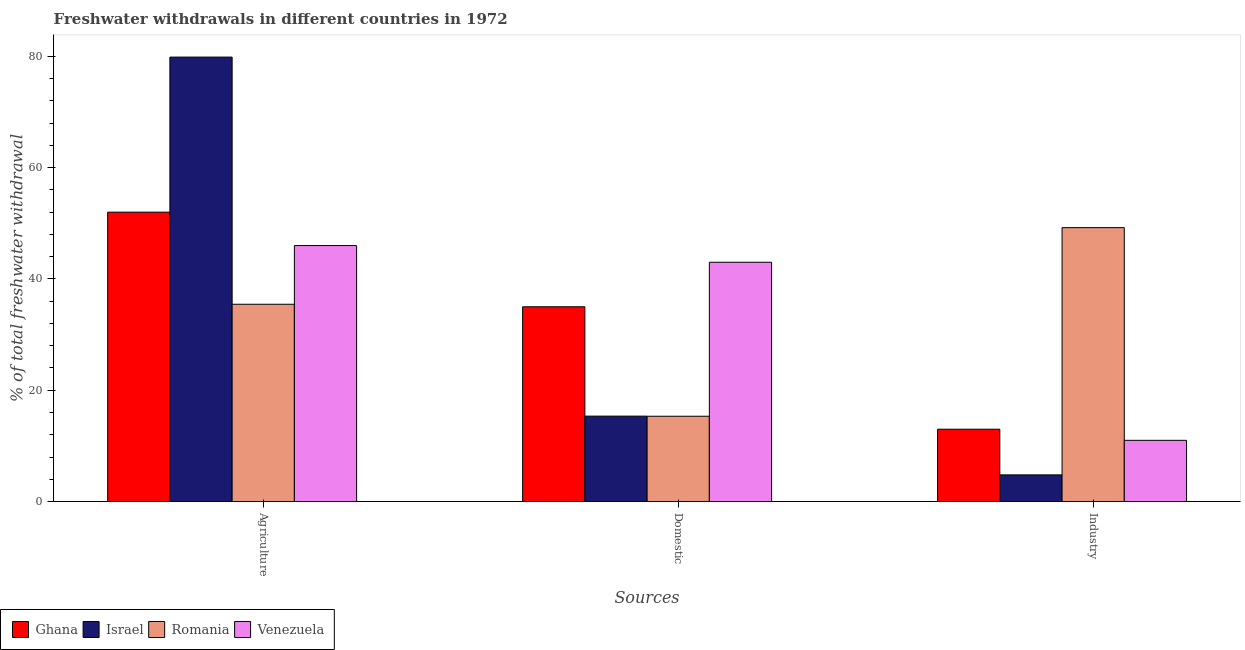How many groups of bars are there?
Provide a short and direct response. 3. Are the number of bars on each tick of the X-axis equal?
Your response must be concise. Yes. How many bars are there on the 3rd tick from the left?
Your answer should be compact. 4. How many bars are there on the 3rd tick from the right?
Provide a short and direct response. 4. What is the label of the 3rd group of bars from the left?
Provide a short and direct response. Industry. Across all countries, what is the maximum percentage of freshwater withdrawal for industry?
Keep it short and to the point. 49.22. Across all countries, what is the minimum percentage of freshwater withdrawal for agriculture?
Your answer should be very brief. 35.45. In which country was the percentage of freshwater withdrawal for agriculture maximum?
Your answer should be compact. Israel. In which country was the percentage of freshwater withdrawal for agriculture minimum?
Your answer should be very brief. Romania. What is the total percentage of freshwater withdrawal for domestic purposes in the graph?
Provide a succinct answer. 108.68. What is the difference between the percentage of freshwater withdrawal for agriculture in Venezuela and that in Israel?
Your response must be concise. -33.86. What is the difference between the percentage of freshwater withdrawal for agriculture in Venezuela and the percentage of freshwater withdrawal for industry in Ghana?
Offer a terse response. 33. What is the average percentage of freshwater withdrawal for domestic purposes per country?
Keep it short and to the point. 27.17. In how many countries, is the percentage of freshwater withdrawal for domestic purposes greater than 76 %?
Keep it short and to the point. 0. What is the ratio of the percentage of freshwater withdrawal for domestic purposes in Venezuela to that in Romania?
Offer a very short reply. 2.8. Is the difference between the percentage of freshwater withdrawal for agriculture in Romania and Ghana greater than the difference between the percentage of freshwater withdrawal for domestic purposes in Romania and Ghana?
Your response must be concise. Yes. What is the difference between the highest and the second highest percentage of freshwater withdrawal for agriculture?
Offer a terse response. 27.86. What is the difference between the highest and the lowest percentage of freshwater withdrawal for domestic purposes?
Give a very brief answer. 27.67. What does the 2nd bar from the right in Agriculture represents?
Provide a short and direct response. Romania. Are all the bars in the graph horizontal?
Provide a short and direct response. No. What is the title of the graph?
Your answer should be very brief. Freshwater withdrawals in different countries in 1972. Does "Angola" appear as one of the legend labels in the graph?
Offer a terse response. No. What is the label or title of the X-axis?
Your answer should be very brief. Sources. What is the label or title of the Y-axis?
Your answer should be very brief. % of total freshwater withdrawal. What is the % of total freshwater withdrawal in Israel in Agriculture?
Your response must be concise. 79.86. What is the % of total freshwater withdrawal in Romania in Agriculture?
Provide a short and direct response. 35.45. What is the % of total freshwater withdrawal in Venezuela in Agriculture?
Your response must be concise. 46. What is the % of total freshwater withdrawal of Israel in Domestic?
Keep it short and to the point. 15.35. What is the % of total freshwater withdrawal of Romania in Domestic?
Your answer should be very brief. 15.33. What is the % of total freshwater withdrawal of Ghana in Industry?
Keep it short and to the point. 13. What is the % of total freshwater withdrawal of Israel in Industry?
Provide a short and direct response. 4.79. What is the % of total freshwater withdrawal in Romania in Industry?
Provide a succinct answer. 49.22. Across all Sources, what is the maximum % of total freshwater withdrawal in Ghana?
Offer a terse response. 52. Across all Sources, what is the maximum % of total freshwater withdrawal of Israel?
Keep it short and to the point. 79.86. Across all Sources, what is the maximum % of total freshwater withdrawal of Romania?
Give a very brief answer. 49.22. Across all Sources, what is the maximum % of total freshwater withdrawal in Venezuela?
Make the answer very short. 46. Across all Sources, what is the minimum % of total freshwater withdrawal of Ghana?
Keep it short and to the point. 13. Across all Sources, what is the minimum % of total freshwater withdrawal in Israel?
Your response must be concise. 4.79. Across all Sources, what is the minimum % of total freshwater withdrawal of Romania?
Give a very brief answer. 15.33. Across all Sources, what is the minimum % of total freshwater withdrawal in Venezuela?
Your response must be concise. 11. What is the total % of total freshwater withdrawal of Ghana in the graph?
Your response must be concise. 100. What is the total % of total freshwater withdrawal of Israel in the graph?
Your answer should be compact. 100. What is the total % of total freshwater withdrawal of Romania in the graph?
Ensure brevity in your answer.  100. What is the total % of total freshwater withdrawal of Venezuela in the graph?
Ensure brevity in your answer.  100. What is the difference between the % of total freshwater withdrawal in Ghana in Agriculture and that in Domestic?
Make the answer very short. 17. What is the difference between the % of total freshwater withdrawal of Israel in Agriculture and that in Domestic?
Your answer should be very brief. 64.51. What is the difference between the % of total freshwater withdrawal in Romania in Agriculture and that in Domestic?
Provide a succinct answer. 20.12. What is the difference between the % of total freshwater withdrawal of Venezuela in Agriculture and that in Domestic?
Provide a succinct answer. 3. What is the difference between the % of total freshwater withdrawal in Israel in Agriculture and that in Industry?
Provide a short and direct response. 75.06. What is the difference between the % of total freshwater withdrawal of Romania in Agriculture and that in Industry?
Provide a succinct answer. -13.77. What is the difference between the % of total freshwater withdrawal of Venezuela in Agriculture and that in Industry?
Offer a very short reply. 35. What is the difference between the % of total freshwater withdrawal in Ghana in Domestic and that in Industry?
Your response must be concise. 22. What is the difference between the % of total freshwater withdrawal in Israel in Domestic and that in Industry?
Make the answer very short. 10.55. What is the difference between the % of total freshwater withdrawal of Romania in Domestic and that in Industry?
Keep it short and to the point. -33.89. What is the difference between the % of total freshwater withdrawal of Ghana in Agriculture and the % of total freshwater withdrawal of Israel in Domestic?
Keep it short and to the point. 36.65. What is the difference between the % of total freshwater withdrawal of Ghana in Agriculture and the % of total freshwater withdrawal of Romania in Domestic?
Offer a very short reply. 36.67. What is the difference between the % of total freshwater withdrawal of Israel in Agriculture and the % of total freshwater withdrawal of Romania in Domestic?
Your answer should be very brief. 64.53. What is the difference between the % of total freshwater withdrawal in Israel in Agriculture and the % of total freshwater withdrawal in Venezuela in Domestic?
Provide a succinct answer. 36.86. What is the difference between the % of total freshwater withdrawal of Romania in Agriculture and the % of total freshwater withdrawal of Venezuela in Domestic?
Provide a succinct answer. -7.55. What is the difference between the % of total freshwater withdrawal in Ghana in Agriculture and the % of total freshwater withdrawal in Israel in Industry?
Make the answer very short. 47.2. What is the difference between the % of total freshwater withdrawal in Ghana in Agriculture and the % of total freshwater withdrawal in Romania in Industry?
Provide a succinct answer. 2.78. What is the difference between the % of total freshwater withdrawal of Israel in Agriculture and the % of total freshwater withdrawal of Romania in Industry?
Make the answer very short. 30.64. What is the difference between the % of total freshwater withdrawal in Israel in Agriculture and the % of total freshwater withdrawal in Venezuela in Industry?
Your answer should be very brief. 68.86. What is the difference between the % of total freshwater withdrawal in Romania in Agriculture and the % of total freshwater withdrawal in Venezuela in Industry?
Your answer should be very brief. 24.45. What is the difference between the % of total freshwater withdrawal of Ghana in Domestic and the % of total freshwater withdrawal of Israel in Industry?
Make the answer very short. 30.2. What is the difference between the % of total freshwater withdrawal of Ghana in Domestic and the % of total freshwater withdrawal of Romania in Industry?
Give a very brief answer. -14.22. What is the difference between the % of total freshwater withdrawal in Ghana in Domestic and the % of total freshwater withdrawal in Venezuela in Industry?
Give a very brief answer. 24. What is the difference between the % of total freshwater withdrawal of Israel in Domestic and the % of total freshwater withdrawal of Romania in Industry?
Give a very brief answer. -33.87. What is the difference between the % of total freshwater withdrawal in Israel in Domestic and the % of total freshwater withdrawal in Venezuela in Industry?
Your response must be concise. 4.35. What is the difference between the % of total freshwater withdrawal of Romania in Domestic and the % of total freshwater withdrawal of Venezuela in Industry?
Offer a terse response. 4.33. What is the average % of total freshwater withdrawal of Ghana per Sources?
Offer a very short reply. 33.33. What is the average % of total freshwater withdrawal in Israel per Sources?
Your response must be concise. 33.34. What is the average % of total freshwater withdrawal of Romania per Sources?
Your response must be concise. 33.33. What is the average % of total freshwater withdrawal of Venezuela per Sources?
Your answer should be very brief. 33.33. What is the difference between the % of total freshwater withdrawal in Ghana and % of total freshwater withdrawal in Israel in Agriculture?
Provide a succinct answer. -27.86. What is the difference between the % of total freshwater withdrawal of Ghana and % of total freshwater withdrawal of Romania in Agriculture?
Provide a short and direct response. 16.55. What is the difference between the % of total freshwater withdrawal of Ghana and % of total freshwater withdrawal of Venezuela in Agriculture?
Ensure brevity in your answer.  6. What is the difference between the % of total freshwater withdrawal in Israel and % of total freshwater withdrawal in Romania in Agriculture?
Give a very brief answer. 44.41. What is the difference between the % of total freshwater withdrawal in Israel and % of total freshwater withdrawal in Venezuela in Agriculture?
Your answer should be very brief. 33.86. What is the difference between the % of total freshwater withdrawal of Romania and % of total freshwater withdrawal of Venezuela in Agriculture?
Make the answer very short. -10.55. What is the difference between the % of total freshwater withdrawal in Ghana and % of total freshwater withdrawal in Israel in Domestic?
Your answer should be compact. 19.65. What is the difference between the % of total freshwater withdrawal in Ghana and % of total freshwater withdrawal in Romania in Domestic?
Your answer should be compact. 19.67. What is the difference between the % of total freshwater withdrawal in Israel and % of total freshwater withdrawal in Venezuela in Domestic?
Your answer should be very brief. -27.65. What is the difference between the % of total freshwater withdrawal of Romania and % of total freshwater withdrawal of Venezuela in Domestic?
Provide a short and direct response. -27.67. What is the difference between the % of total freshwater withdrawal of Ghana and % of total freshwater withdrawal of Israel in Industry?
Make the answer very short. 8.21. What is the difference between the % of total freshwater withdrawal of Ghana and % of total freshwater withdrawal of Romania in Industry?
Your response must be concise. -36.22. What is the difference between the % of total freshwater withdrawal of Ghana and % of total freshwater withdrawal of Venezuela in Industry?
Provide a succinct answer. 2. What is the difference between the % of total freshwater withdrawal in Israel and % of total freshwater withdrawal in Romania in Industry?
Offer a terse response. -44.42. What is the difference between the % of total freshwater withdrawal of Israel and % of total freshwater withdrawal of Venezuela in Industry?
Make the answer very short. -6.21. What is the difference between the % of total freshwater withdrawal of Romania and % of total freshwater withdrawal of Venezuela in Industry?
Provide a short and direct response. 38.22. What is the ratio of the % of total freshwater withdrawal in Ghana in Agriculture to that in Domestic?
Give a very brief answer. 1.49. What is the ratio of the % of total freshwater withdrawal in Israel in Agriculture to that in Domestic?
Keep it short and to the point. 5.2. What is the ratio of the % of total freshwater withdrawal in Romania in Agriculture to that in Domestic?
Make the answer very short. 2.31. What is the ratio of the % of total freshwater withdrawal in Venezuela in Agriculture to that in Domestic?
Offer a very short reply. 1.07. What is the ratio of the % of total freshwater withdrawal in Israel in Agriculture to that in Industry?
Offer a terse response. 16.65. What is the ratio of the % of total freshwater withdrawal of Romania in Agriculture to that in Industry?
Offer a very short reply. 0.72. What is the ratio of the % of total freshwater withdrawal in Venezuela in Agriculture to that in Industry?
Your answer should be very brief. 4.18. What is the ratio of the % of total freshwater withdrawal in Ghana in Domestic to that in Industry?
Give a very brief answer. 2.69. What is the ratio of the % of total freshwater withdrawal in Israel in Domestic to that in Industry?
Provide a succinct answer. 3.2. What is the ratio of the % of total freshwater withdrawal in Romania in Domestic to that in Industry?
Your response must be concise. 0.31. What is the ratio of the % of total freshwater withdrawal in Venezuela in Domestic to that in Industry?
Keep it short and to the point. 3.91. What is the difference between the highest and the second highest % of total freshwater withdrawal of Israel?
Provide a short and direct response. 64.51. What is the difference between the highest and the second highest % of total freshwater withdrawal of Romania?
Ensure brevity in your answer.  13.77. What is the difference between the highest and the second highest % of total freshwater withdrawal of Venezuela?
Keep it short and to the point. 3. What is the difference between the highest and the lowest % of total freshwater withdrawal in Ghana?
Offer a very short reply. 39. What is the difference between the highest and the lowest % of total freshwater withdrawal in Israel?
Give a very brief answer. 75.06. What is the difference between the highest and the lowest % of total freshwater withdrawal of Romania?
Your response must be concise. 33.89. 